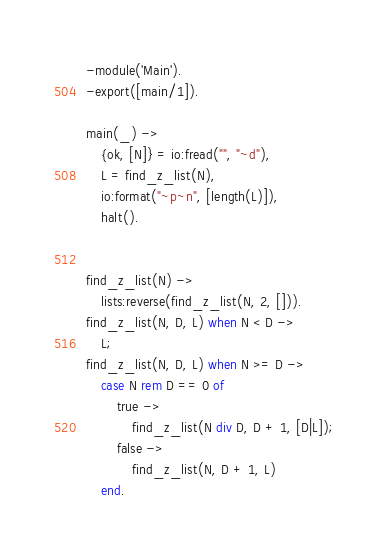<code> <loc_0><loc_0><loc_500><loc_500><_Erlang_>-module('Main').
-export([main/1]).

main(_) ->
    {ok, [N]} = io:fread("", "~d"),
    L = find_z_list(N),
    io:format("~p~n", [length(L)]),
    halt().


find_z_list(N) ->
    lists:reverse(find_z_list(N, 2, [])).
find_z_list(N, D, L) when N < D ->
    L;
find_z_list(N, D, L) when N >= D ->
    case N rem D == 0 of
        true ->
            find_z_list(N div D, D + 1, [D|L]);
        false ->
            find_z_list(N, D + 1, L)
    end.

</code> 